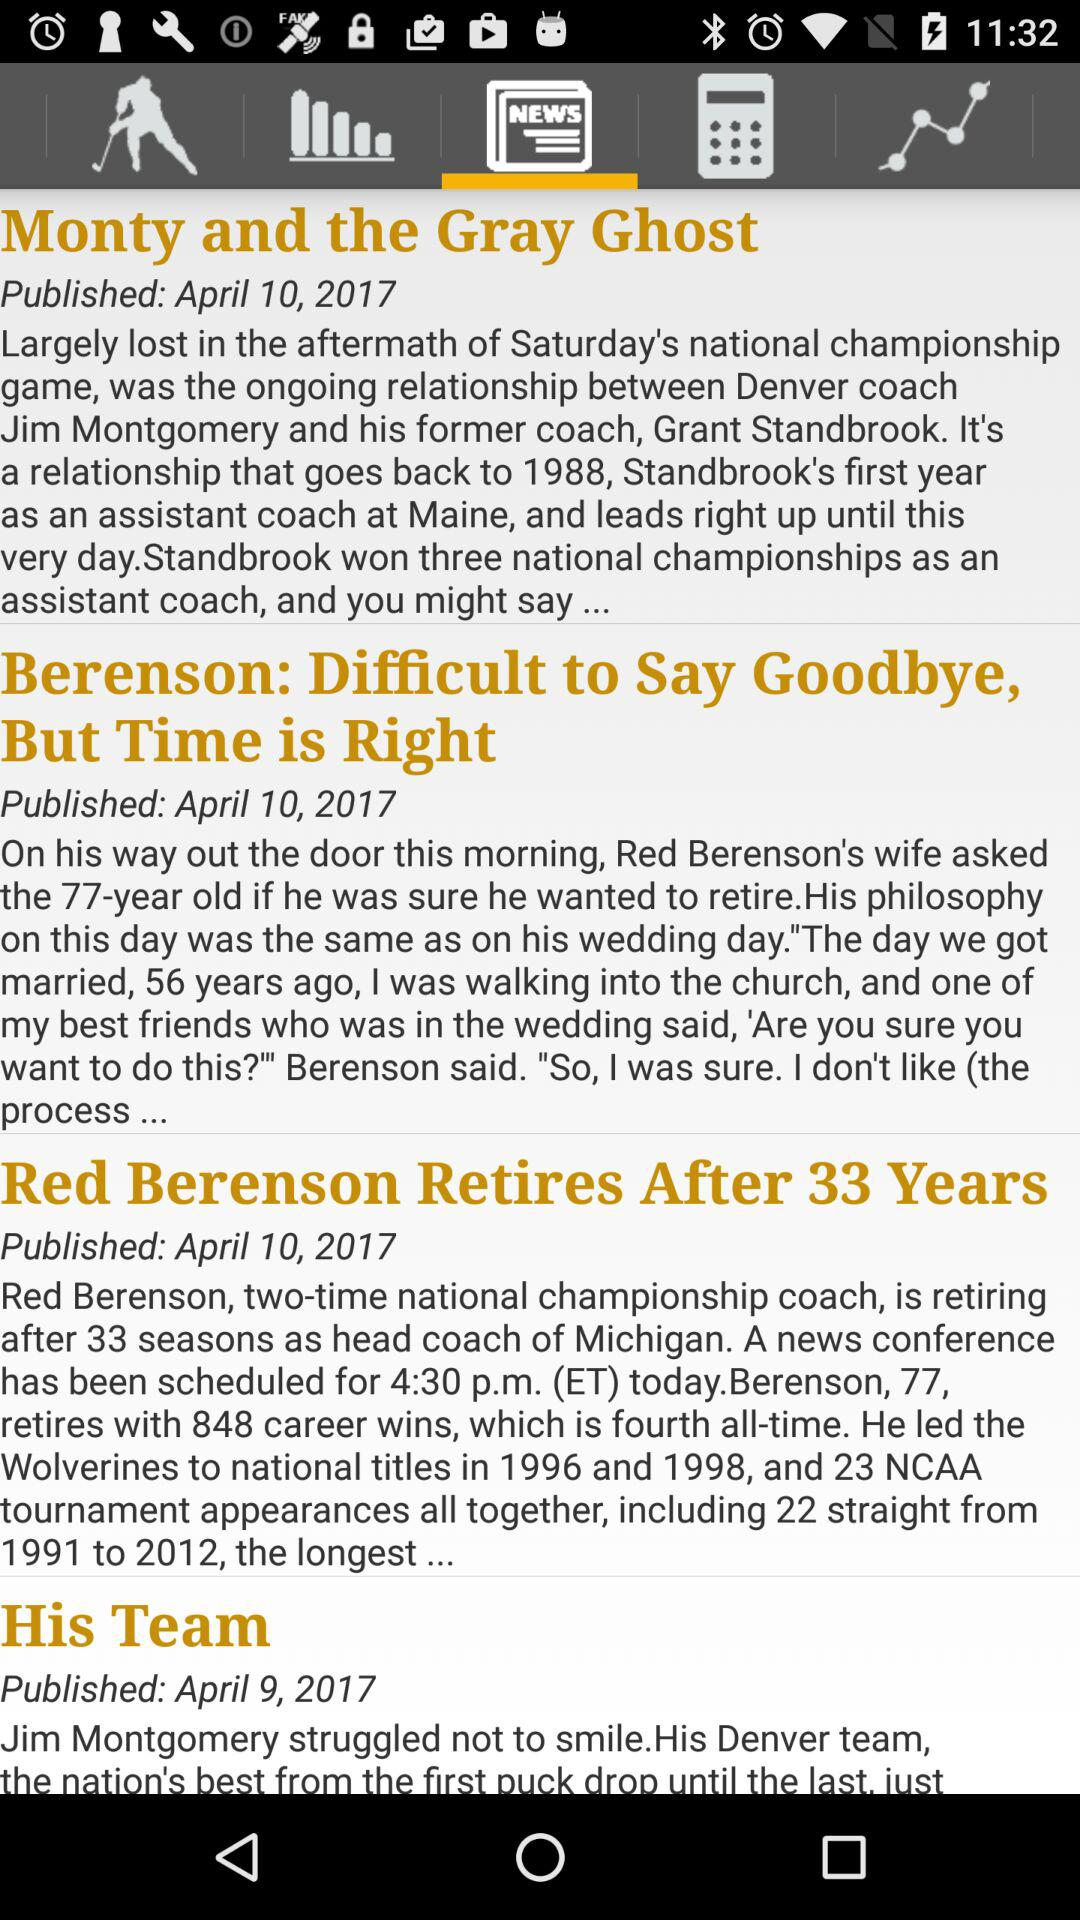When was the article "His Team" published? The article "His Team" was published on April 9, 2017. 